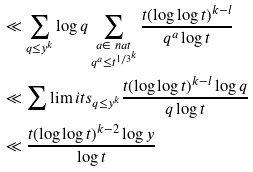Convert formula to latex. <formula><loc_0><loc_0><loc_500><loc_500>& \ll \sum _ { q \leq y ^ { k } } \log q \sum _ { \substack { a \in \ n a t \\ q ^ { a } \leq t ^ { 1 / 3 ^ { k } } } } \frac { t ( \log \log t ) ^ { k - l } } { q ^ { a } \log t } \\ & \ll \sum \lim i t s _ { q \leq y ^ { k } } \frac { t ( \log \log t ) ^ { k - l } \log q } { q \log t } \\ & \ll \frac { t ( \log \log t ) ^ { k - 2 } \log y } { \log t }</formula> 